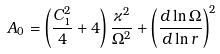<formula> <loc_0><loc_0><loc_500><loc_500>A _ { 0 } = \left ( \frac { C _ { 1 } ^ { 2 } } { 4 } + 4 \right ) \frac { \varkappa ^ { 2 } } { \Omega ^ { 2 } } + \left ( \frac { d \ln \Omega } { d \ln r } \right ) ^ { 2 }</formula> 